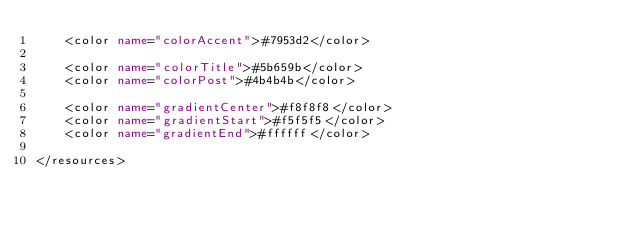Convert code to text. <code><loc_0><loc_0><loc_500><loc_500><_XML_>    <color name="colorAccent">#7953d2</color>

    <color name="colorTitle">#5b659b</color>
    <color name="colorPost">#4b4b4b</color>

    <color name="gradientCenter">#f8f8f8</color>
    <color name="gradientStart">#f5f5f5</color>
    <color name="gradientEnd">#ffffff</color>

</resources>
</code> 